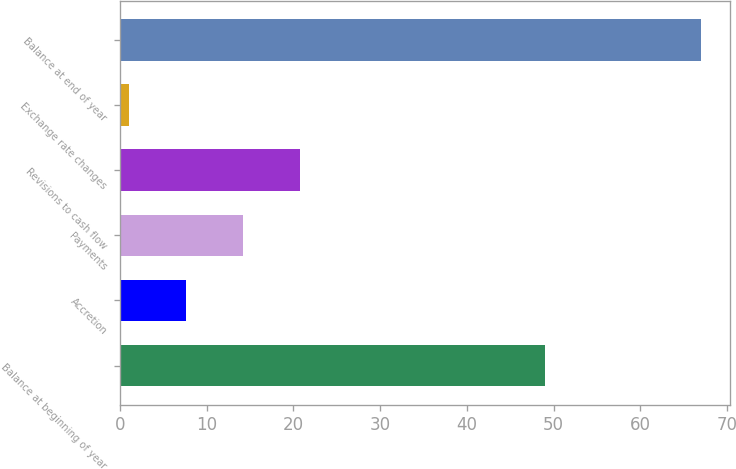Convert chart to OTSL. <chart><loc_0><loc_0><loc_500><loc_500><bar_chart><fcel>Balance at beginning of year<fcel>Accretion<fcel>Payments<fcel>Revisions to cash flow<fcel>Exchange rate changes<fcel>Balance at end of year<nl><fcel>49<fcel>7.6<fcel>14.2<fcel>20.8<fcel>1<fcel>67<nl></chart> 